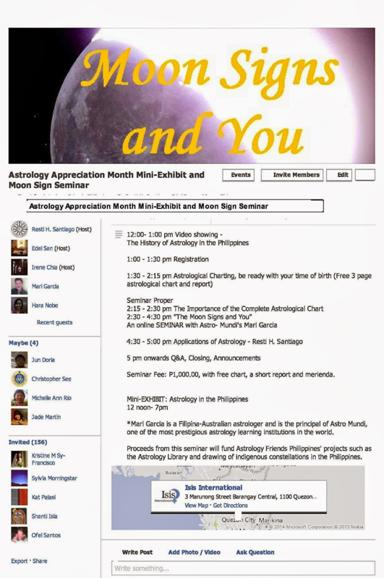Who is the principal of Astro Mundi? Mari Garcia serves as the esteemed principal of Astro Mundi, bringing her wealth of knowledge and expertise in astrology to lead the institution in promoting deeper understanding of astrological sciences. 